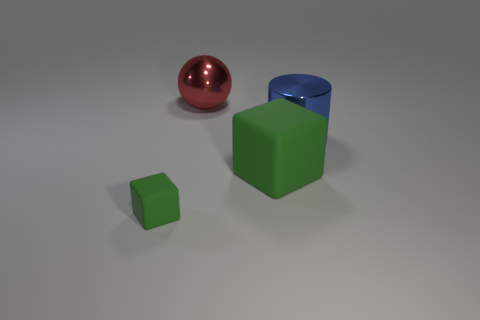What is the shape of the matte object that is the same size as the red sphere?
Keep it short and to the point. Cube. Does the big thing that is behind the metal cylinder have the same color as the big matte block?
Keep it short and to the point. No. What number of objects are big metallic objects on the left side of the blue cylinder or big red objects?
Give a very brief answer. 1. Are there more large cylinders in front of the big cube than tiny cubes that are to the left of the tiny green block?
Make the answer very short. No. Are the small cube and the red thing made of the same material?
Give a very brief answer. No. What shape is the thing that is behind the large rubber object and in front of the large red sphere?
Provide a short and direct response. Cylinder. There is a large thing that is made of the same material as the large ball; what shape is it?
Ensure brevity in your answer.  Cylinder. Are there any green rubber cubes?
Keep it short and to the point. Yes. There is a green object that is to the right of the metal sphere; is there a metallic thing that is left of it?
Ensure brevity in your answer.  Yes. What is the material of the other thing that is the same shape as the big green matte object?
Make the answer very short. Rubber. 